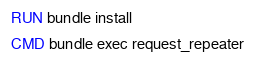Convert code to text. <code><loc_0><loc_0><loc_500><loc_500><_Dockerfile_>RUN bundle install

CMD bundle exec request_repeater
</code> 